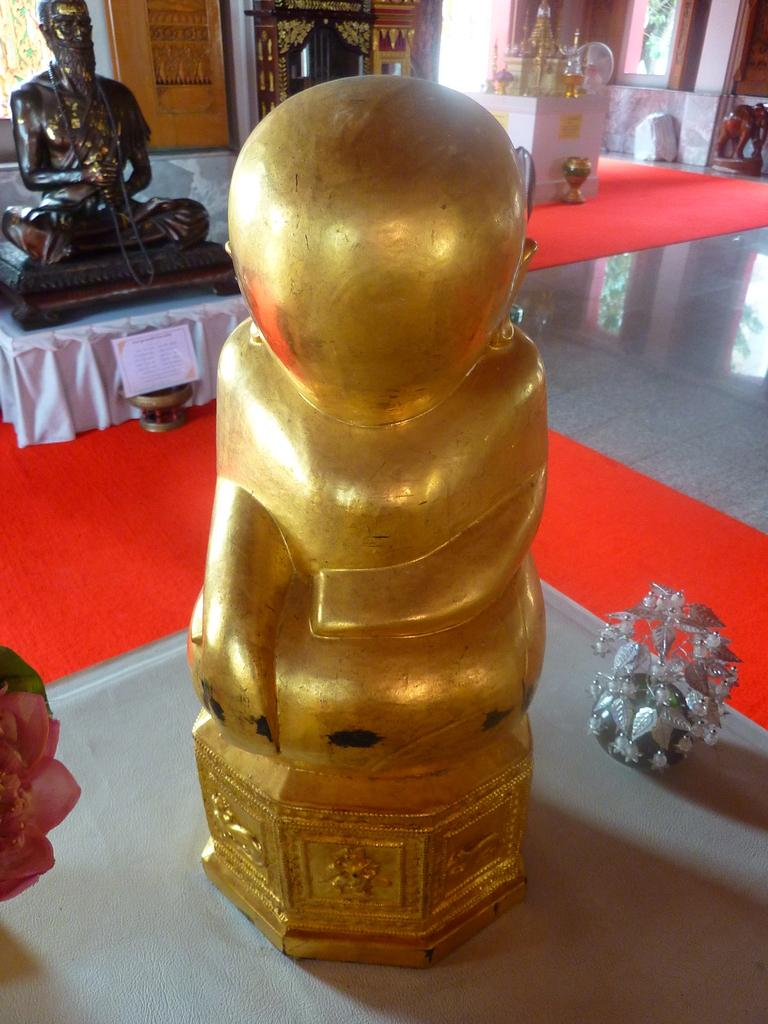What type of objects can be seen in the image? There are sculptures in the image. Where are the sculptures located? The sculptures are placed on a table. In what setting are the sculptures and table located? The table and sculptures are in a room. Can you see any rabbits or frogs in the river near the sculptures? There is no river or rabbits or frogs present in the image; it only features sculptures on a table in a room. 